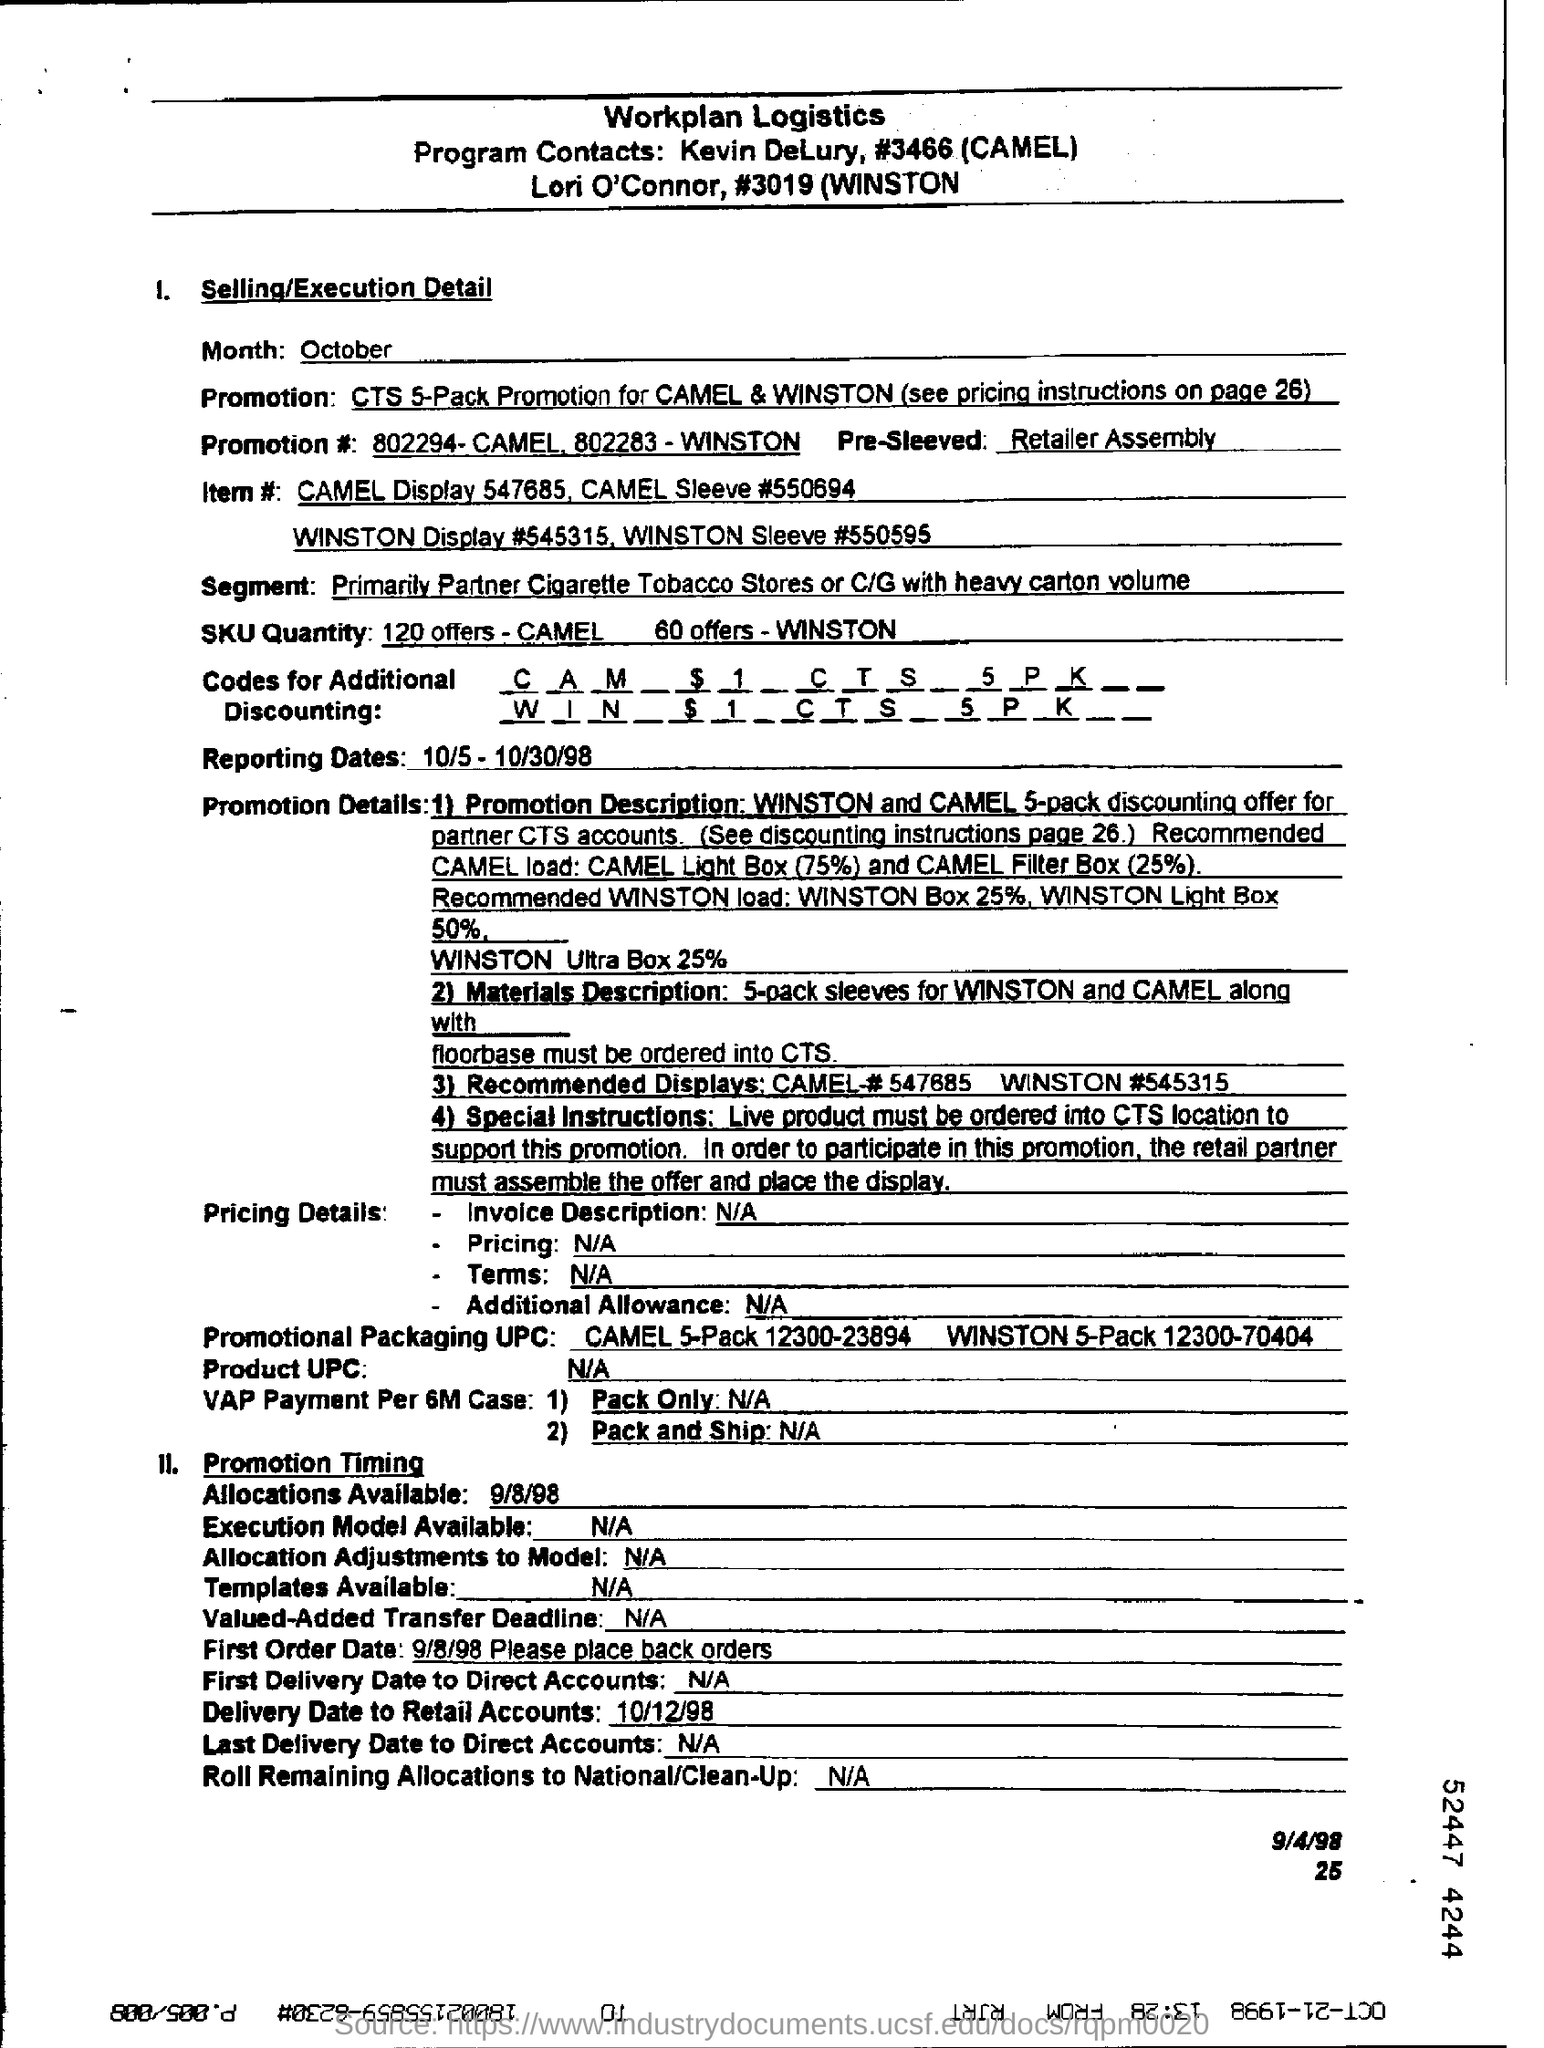Mention a couple of crucial points in this snapshot. The blank pre-sleeved product is written with information provided by the retailer during assembly. The delivery date for retail accounts is 10/12/98. The product's UPC code is not available. The reporting dates for the given period are from October 5th to October 30th, 1998. 